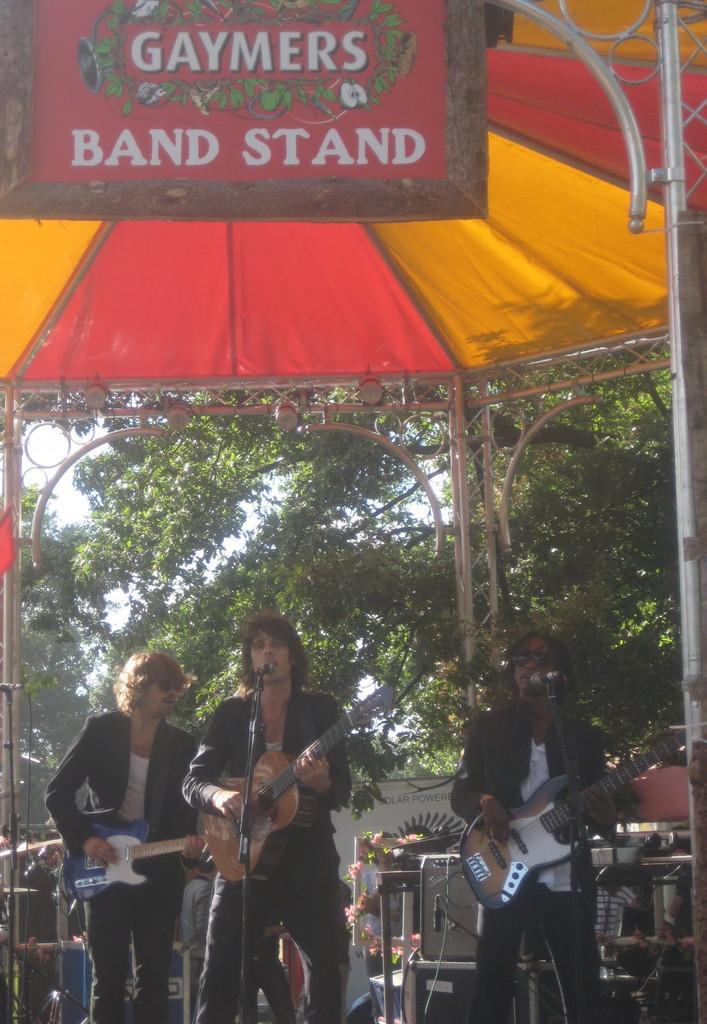Could you give a brief overview of what you see in this image? It is an outdoor picture where three people standing in the middle of the picture and the middle person is holding a guitar and singing a song in the microphone in front of him and in the left corner of the picture one person is holding a guitar and wearing coat and at the right corner of the picture and the person is wearing coat and playing the guitar and back side of them there are trees and these three people are under the tent house and there is one board written text is on that. 